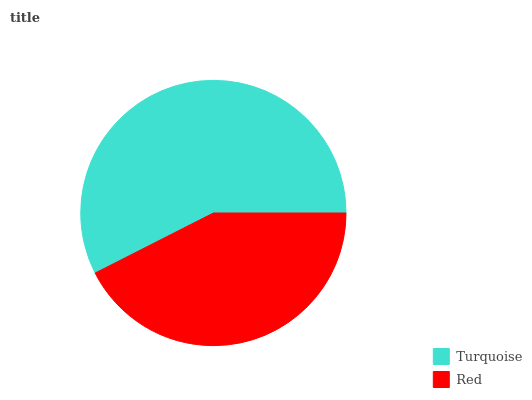Is Red the minimum?
Answer yes or no. Yes. Is Turquoise the maximum?
Answer yes or no. Yes. Is Red the maximum?
Answer yes or no. No. Is Turquoise greater than Red?
Answer yes or no. Yes. Is Red less than Turquoise?
Answer yes or no. Yes. Is Red greater than Turquoise?
Answer yes or no. No. Is Turquoise less than Red?
Answer yes or no. No. Is Turquoise the high median?
Answer yes or no. Yes. Is Red the low median?
Answer yes or no. Yes. Is Red the high median?
Answer yes or no. No. Is Turquoise the low median?
Answer yes or no. No. 